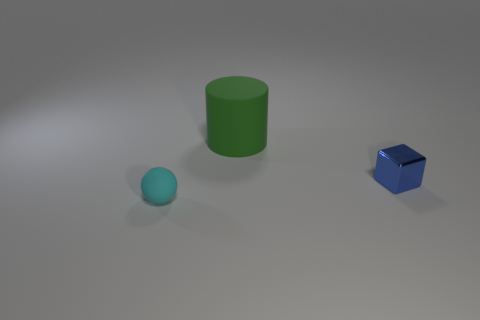Are there any other things that have the same material as the tiny blue block?
Keep it short and to the point. No. What size is the cyan object that is in front of the matte object behind the small cyan object?
Offer a very short reply. Small. How big is the matte thing that is behind the blue cube?
Provide a succinct answer. Large. Is the number of large matte cylinders that are in front of the big rubber cylinder less than the number of small blue metal things to the right of the metallic object?
Offer a terse response. No. What is the color of the large matte cylinder?
Offer a very short reply. Green. Is there a small metallic thing of the same color as the tiny matte thing?
Provide a short and direct response. No. What is the shape of the small thing behind the rubber object to the left of the rubber thing that is on the right side of the tiny matte object?
Give a very brief answer. Cube. There is a object in front of the tiny metal cube; what is its material?
Offer a terse response. Rubber. There is a rubber thing that is left of the large green matte cylinder left of the small thing on the right side of the cyan matte object; what is its size?
Offer a very short reply. Small. Is the size of the blue thing the same as the thing that is left of the green rubber cylinder?
Your answer should be very brief. Yes. 